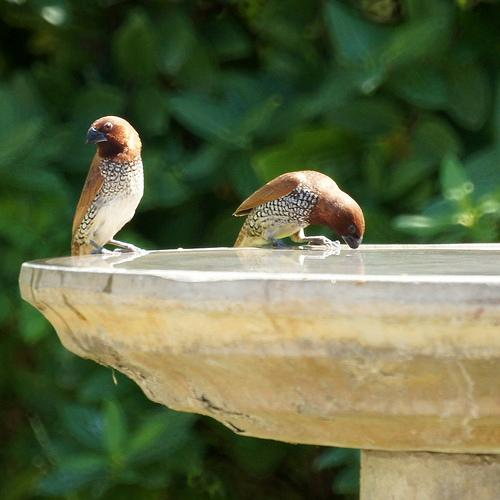What type of plants can be seen in the background, and what is their overall appearance? Green bushes are in the background, appearing out of focus and slightly blurred. Point out the key elements and actions in the picture. Two birds are perched on a stone water fountain, one is drinking from the water while the other looks to its right, with green leaves of bushes in the background. Identify two objects in the scene and describe their interaction with each other. A bird is standing on the edge of a stone water fountain, drinking water from it. What is the focal point of this image and what sentiment does it evoke? The focal point of this image is two birds on a water fountain, evoking a peaceful and serene sentiment. Describe the water fountain and its surroundings. The water fountain is made of stone, has a beige color, and is filled with water; green leaves of bushes are out of focus in the background. Analyze the quality of the image by describing the sharpness and composition of the scene. The image is of high quality, with a sharp focus on the two birds and the water fountain, while the green leaves in the background appear blurred, creating a good composition of the scene. In the image, describe the birds' beaks and the direction they are facing. One bird has a small black beak, facing the water as it drinks; the other brown bird faces its right side with a beak that is not clearly visible. How many birds are present in the image and what are they doing? There are two birds; one is drinking water from the fountain, while the other is perched and looking to its right. Count the number of birds and describe the color of their wings. There are two birds with brown wings in the image. Mention three dominant colors that can be seen in the image. Brown, white, and green are the dominant colors in this image. What caption mentions the position of the birds' feet? "the birds feet are on the fountain" Provide a description of the green plants in the image. Green leaves and bushes are visible behind the birds and fountain, some of which are out of focus. Can you spot the baby kitten hiding behind the fountain? No, it's not mentioned in the image. Which captions refer to a bird drinking water? "bird drinking water from the fountain", "a bird drinking from a bird bath", "a bird drinking water from the bath", "brown bird drinking out of the bird bath", "the bird is drinking water". List the color-related attributes mentioned for the birds and fountain.  Bird: brown, white, black beak; Fountain: stone, tan Did you notice the squirrel climbing onto the birdbath? There is no mention of a squirrel in the list of objects, but by framing it as a question, it can mislead the viewer into searching for a squirrel that isn't there. What emotion is portrayed by the birds in the image? Neutral, as they are engaged in drinking water and perching. What are the contents of the birdbath in the image? Water Identify any bird-specific body parts mentioned in the given information.  Beak, eye, breast, wings, feet, legs, head. What are two birds doing in the image? Drinking water and perched on the fountain. Identify any unusual aspects of the image according to the given information. No unusual aspects are mentioned in the information. Find any text within the image. No text is mentioned in the given information. Evaluate the image quality based on the detailed captions. The image quality is high, as many subtle details of the birds and fountain are mentioned. Name the activities of the birds in the image. Drinking water and perching on the fountain. Select the best option for a caption of the fountain: a) a wooden fountain b) a stone water fountain c) a metal water fountain. b) a stone water fountain What is the location of the green leaves in relation to the birds? Green leaves are positioned behind the birds. What body part of the bird is small according to one of the captions? Beak What color is the bird's beak mentioned in one of the captions? Black How many birds are shown in the image? Two birds What material is the fountain made of according to the captions? Stone Describe the main objects in the image. There are two birds standing on a stone water fountain filled with water, surrounded by green leaves. 